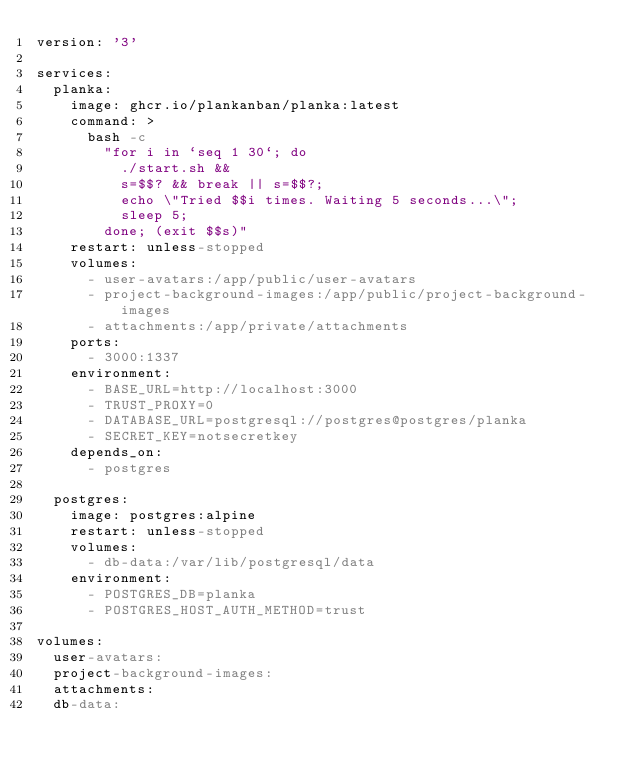Convert code to text. <code><loc_0><loc_0><loc_500><loc_500><_YAML_>version: '3'

services:
  planka:
    image: ghcr.io/plankanban/planka:latest
    command: >
      bash -c
        "for i in `seq 1 30`; do
          ./start.sh &&
          s=$$? && break || s=$$?;
          echo \"Tried $$i times. Waiting 5 seconds...\";
          sleep 5;
        done; (exit $$s)"
    restart: unless-stopped
    volumes:
      - user-avatars:/app/public/user-avatars
      - project-background-images:/app/public/project-background-images
      - attachments:/app/private/attachments
    ports:
      - 3000:1337
    environment:
      - BASE_URL=http://localhost:3000
      - TRUST_PROXY=0
      - DATABASE_URL=postgresql://postgres@postgres/planka
      - SECRET_KEY=notsecretkey
    depends_on:
      - postgres

  postgres:
    image: postgres:alpine
    restart: unless-stopped
    volumes:
      - db-data:/var/lib/postgresql/data
    environment:
      - POSTGRES_DB=planka
      - POSTGRES_HOST_AUTH_METHOD=trust

volumes:
  user-avatars:
  project-background-images:
  attachments:
  db-data:
</code> 